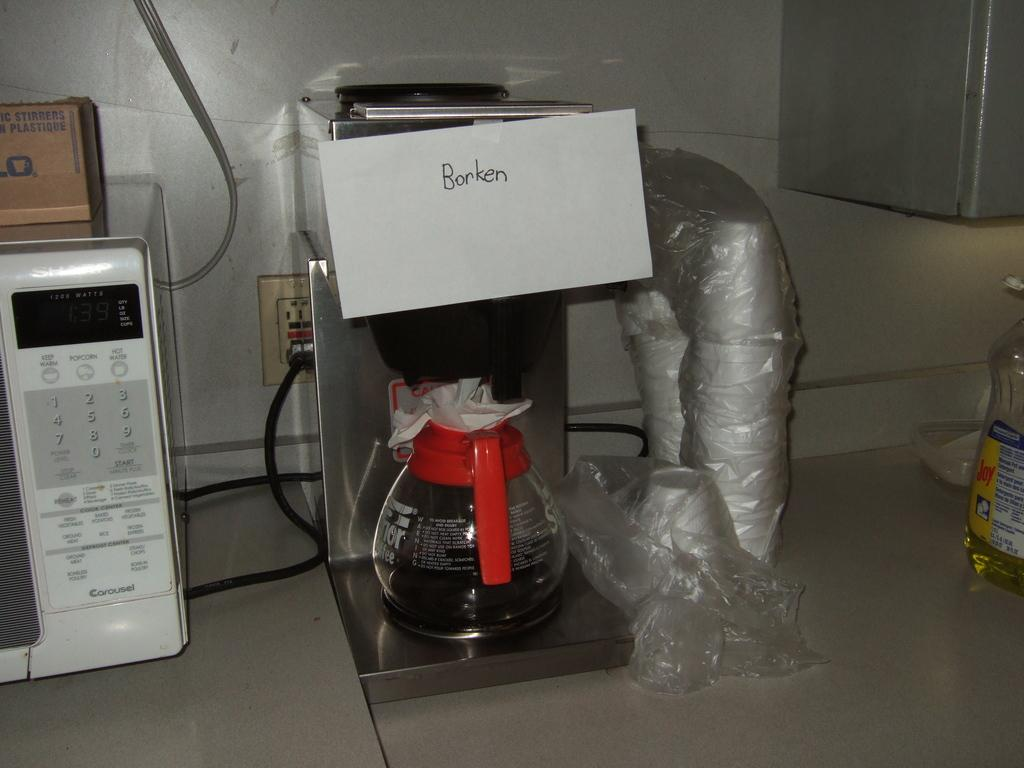<image>
Relay a brief, clear account of the picture shown. A coffee maker with the word Borken pinned on it 